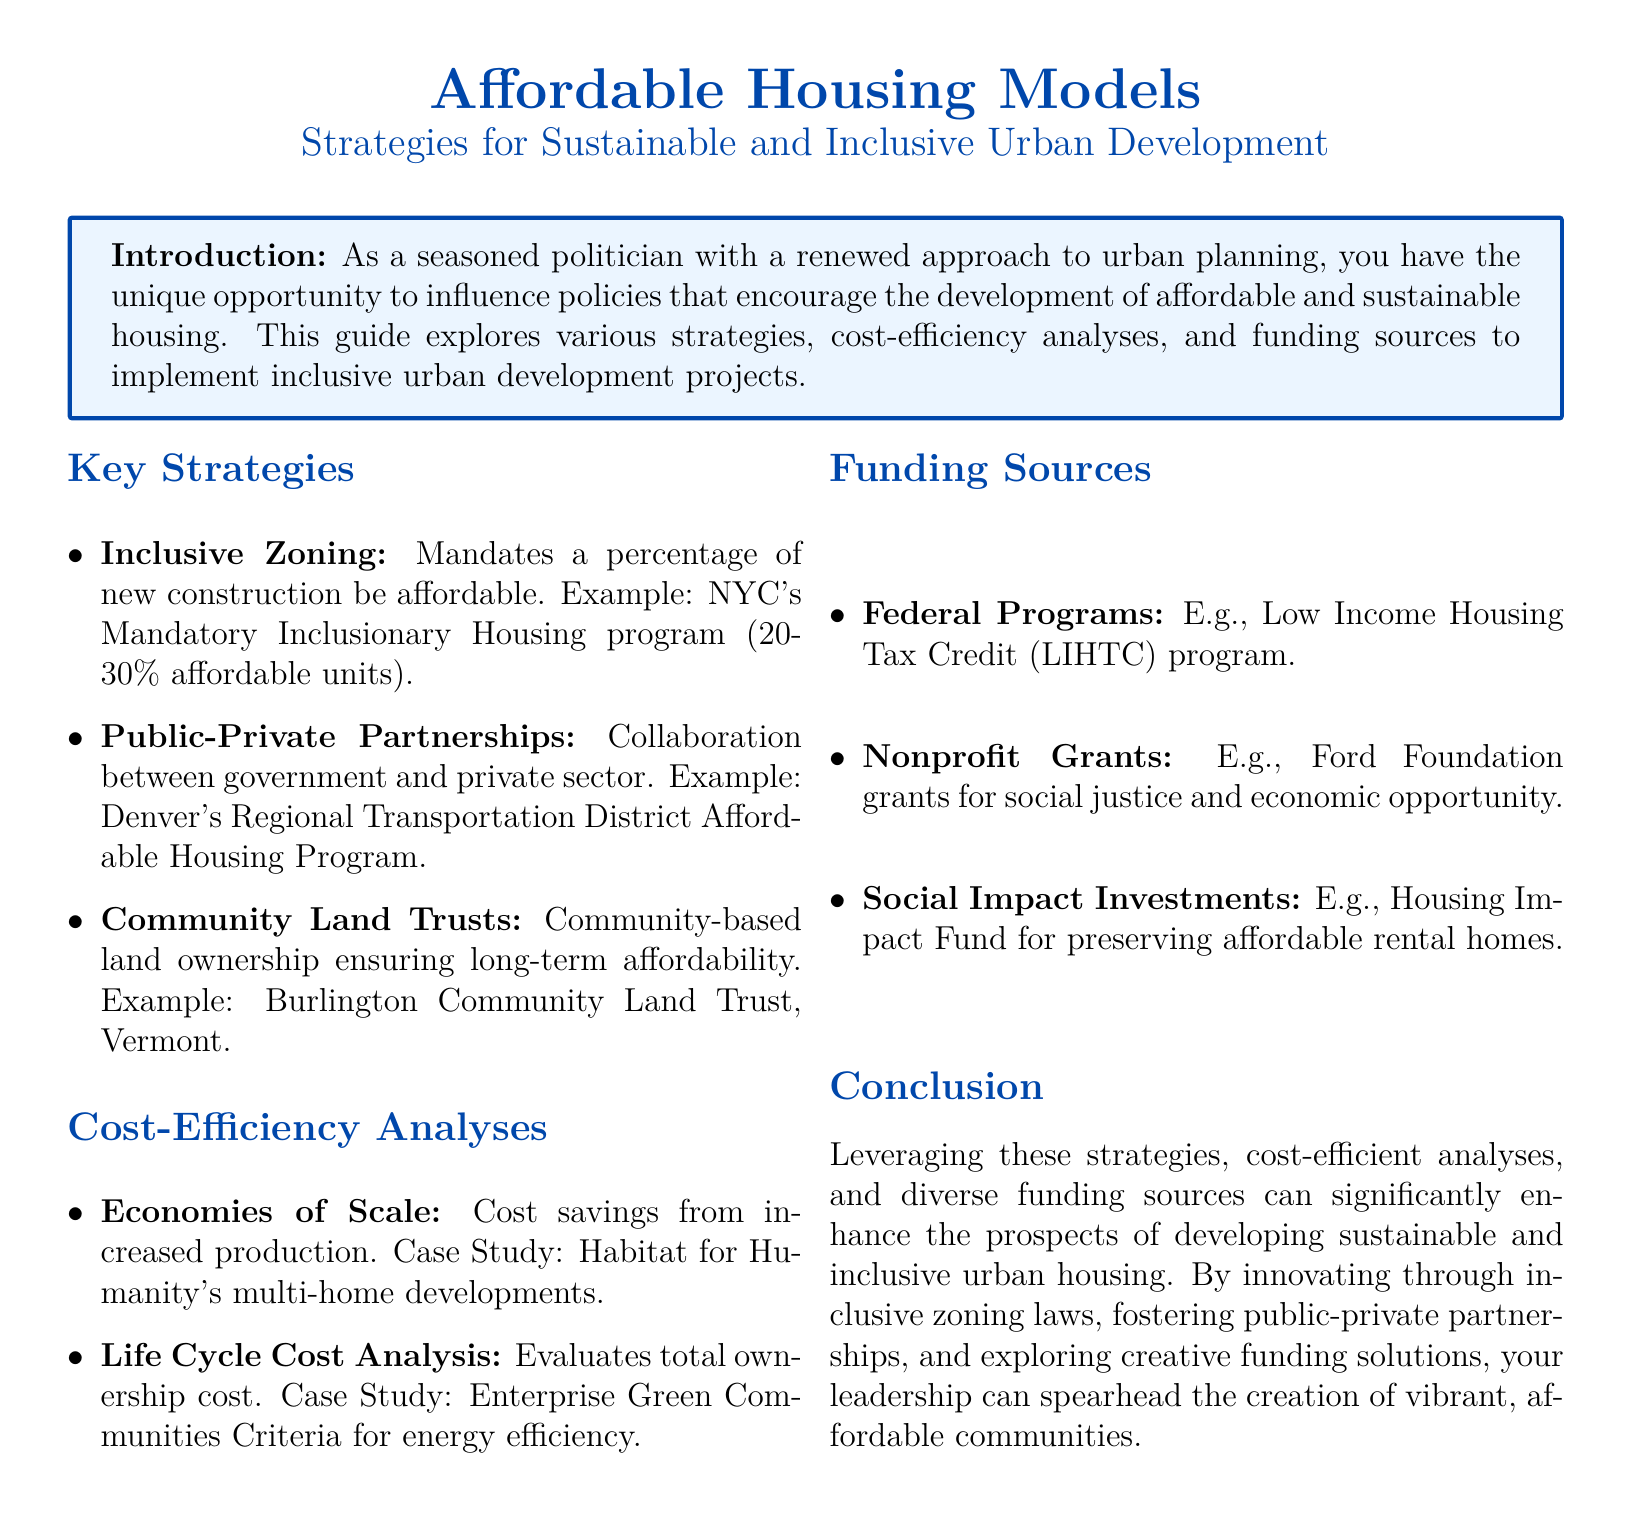What is the title of the guide? The title is explicitly stated at the top of the document as "Affordable Housing Models."
Answer: Affordable Housing Models What is a key strategy for urban development mentioned in the document? The document lists several strategies under the "Key Strategies" section; one example is "Inclusive Zoning."
Answer: Inclusive Zoning What percentage of affordable units is mandated by NYC's Mandatory Inclusionary Housing program? The specific percentage is mentioned in the explanation of Inclusive Zoning within the document.
Answer: 20-30% Which funding source is mentioned as a federal program? The document specifically names the "Low Income Housing Tax Credit" program as a federal funding source.
Answer: Low Income Housing Tax Credit What organization is referenced in the case study for Economies of Scale? The document provides a specific example related to the case study under Cost-Efficiency Analyses.
Answer: Habitat for Humanity How does the document categorize its content? The document is structured into distinct sections, including "Key Strategies," "Cost-Efficiency Analyses," and "Funding Sources."
Answer: Sections What type of partnerships are emphasized in the document for affordable housing? The document stresses the importance of partnerships that involve collaboration, leading to a specific term being highlighted.
Answer: Public-Private Partnerships What is a focus area for funding sources highlighted in the guide? Multiple sources are mentioned, one specifically is noted for social justice efforts.
Answer: Nonprofit Grants 